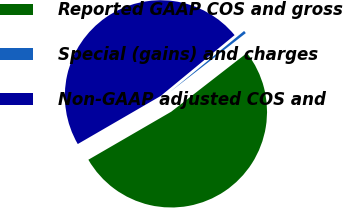Convert chart. <chart><loc_0><loc_0><loc_500><loc_500><pie_chart><fcel>Reported GAAP COS and gross<fcel>Special (gains) and charges<fcel>Non-GAAP adjusted COS and<nl><fcel>52.14%<fcel>0.46%<fcel>47.4%<nl></chart> 